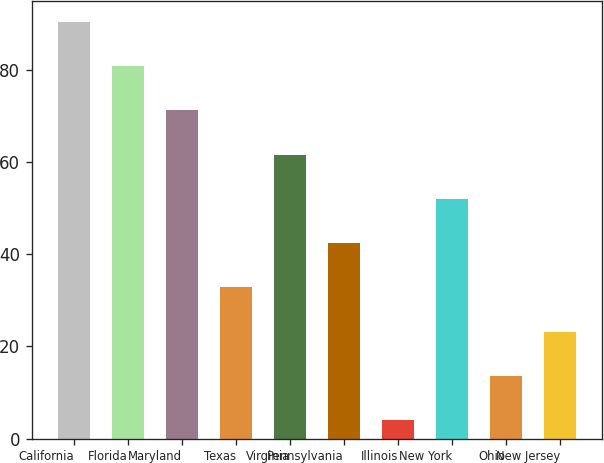Convert chart to OTSL. <chart><loc_0><loc_0><loc_500><loc_500><bar_chart><fcel>California<fcel>Florida<fcel>Maryland<fcel>Texas<fcel>Virginia<fcel>Pennsylvania<fcel>Illinois<fcel>New York<fcel>Ohio<fcel>New Jersey<nl><fcel>90.4<fcel>80.8<fcel>71.2<fcel>32.8<fcel>61.6<fcel>42.4<fcel>4<fcel>52<fcel>13.6<fcel>23.2<nl></chart> 